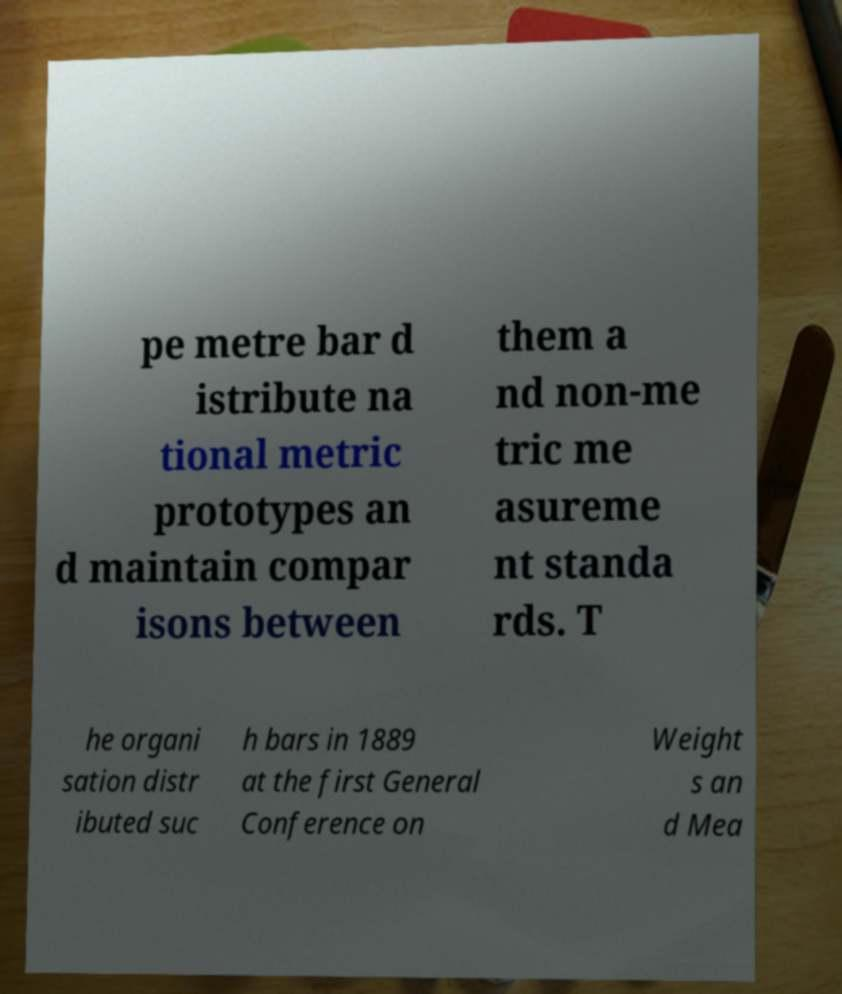Can you read and provide the text displayed in the image?This photo seems to have some interesting text. Can you extract and type it out for me? pe metre bar d istribute na tional metric prototypes an d maintain compar isons between them a nd non-me tric me asureme nt standa rds. T he organi sation distr ibuted suc h bars in 1889 at the first General Conference on Weight s an d Mea 